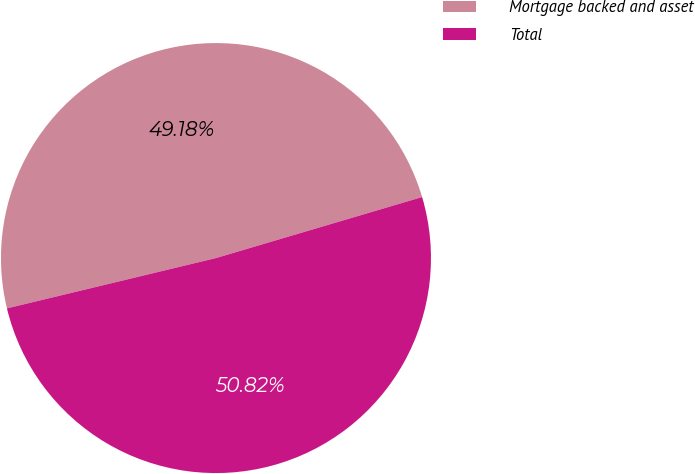Convert chart to OTSL. <chart><loc_0><loc_0><loc_500><loc_500><pie_chart><fcel>Mortgage backed and asset<fcel>Total<nl><fcel>49.18%<fcel>50.82%<nl></chart> 